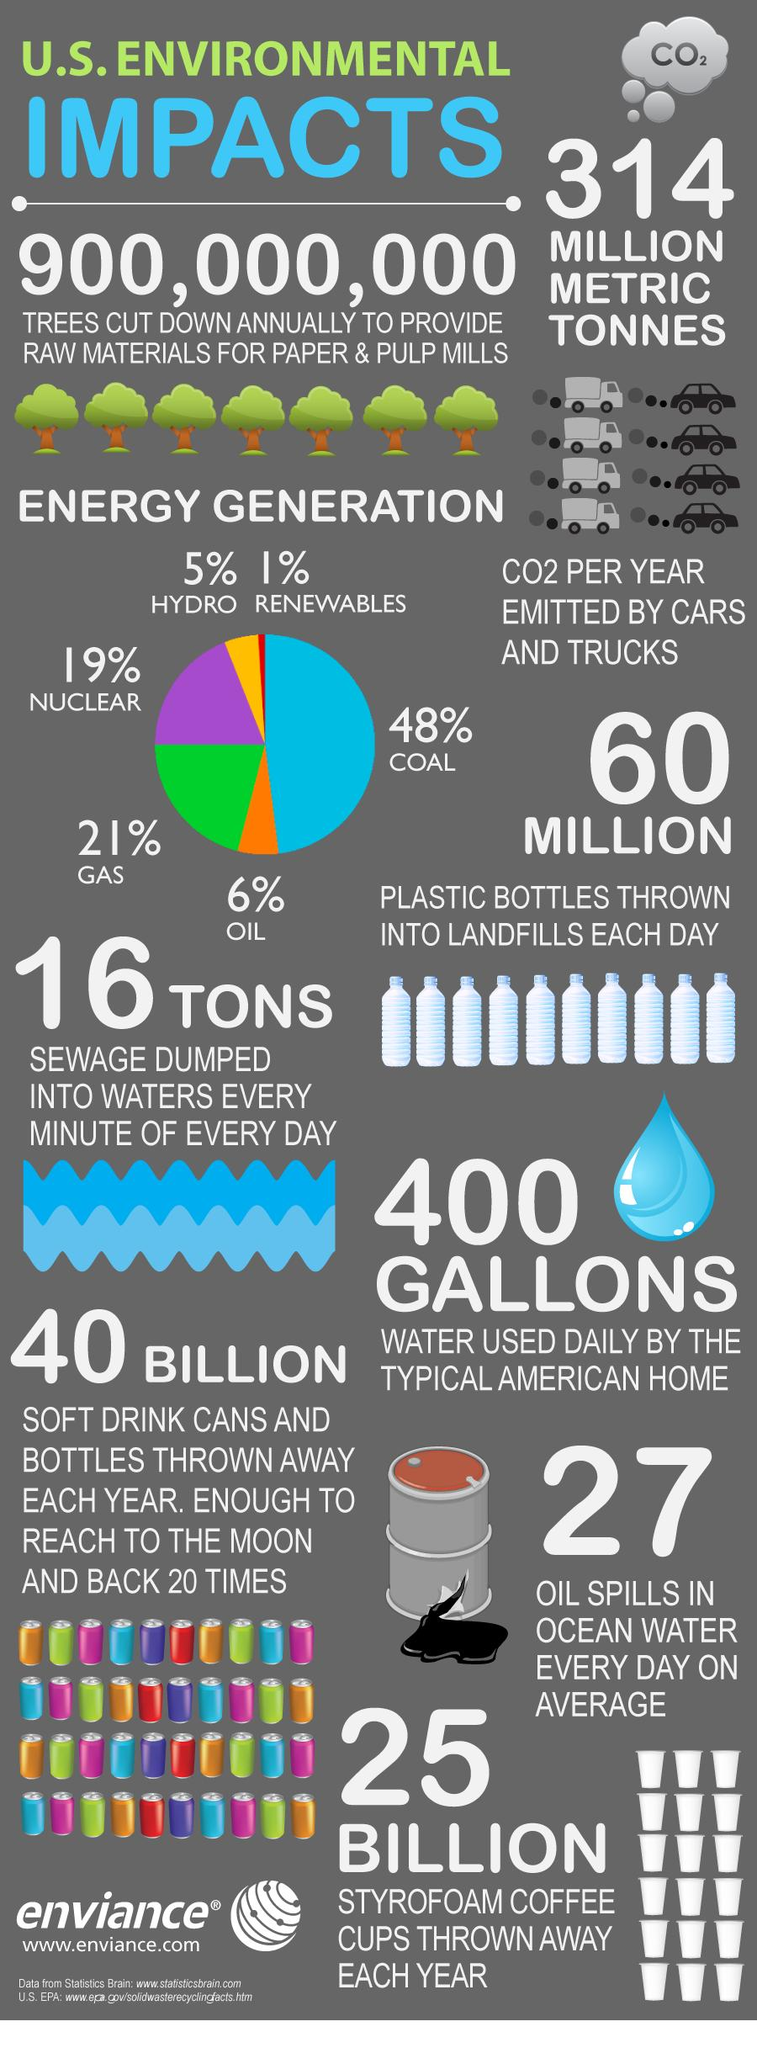Indicate a few pertinent items in this graphic. Coal generates the maximum amount of energy. It would take approximately 40 billion soft drink cans and bottles to reach the moon and return 20 times. It is estimated that approximately 314 million metric tonnes of CO2 are emitted by cars and trucks annually. The amount of energy generated by gas and oil is approximately 27%. The gas mentioned is CO2. 